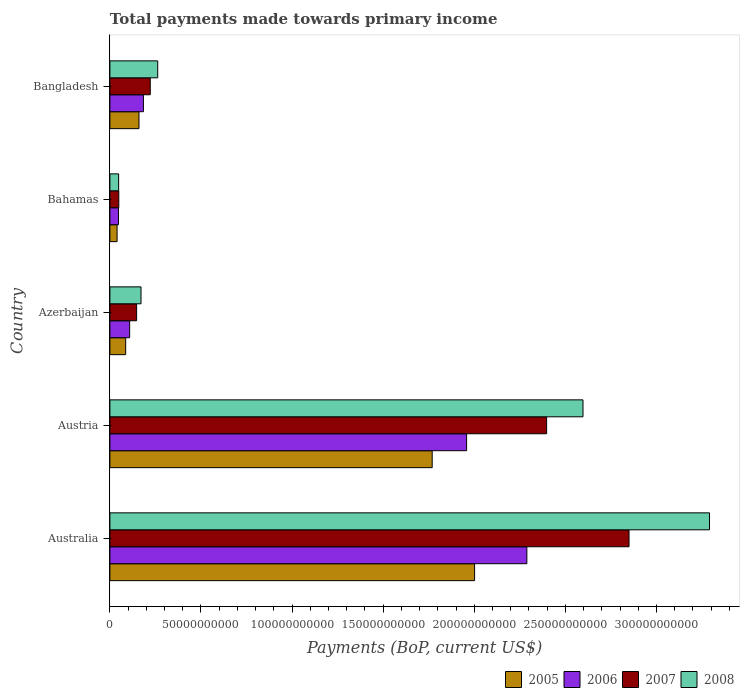How many groups of bars are there?
Provide a succinct answer. 5. Are the number of bars per tick equal to the number of legend labels?
Give a very brief answer. Yes. Are the number of bars on each tick of the Y-axis equal?
Your answer should be compact. Yes. How many bars are there on the 2nd tick from the top?
Give a very brief answer. 4. How many bars are there on the 3rd tick from the bottom?
Your answer should be very brief. 4. What is the label of the 2nd group of bars from the top?
Give a very brief answer. Bahamas. In how many cases, is the number of bars for a given country not equal to the number of legend labels?
Ensure brevity in your answer.  0. What is the total payments made towards primary income in 2005 in Azerbaijan?
Offer a terse response. 8.66e+09. Across all countries, what is the maximum total payments made towards primary income in 2007?
Your response must be concise. 2.85e+11. Across all countries, what is the minimum total payments made towards primary income in 2008?
Offer a terse response. 4.80e+09. In which country was the total payments made towards primary income in 2007 maximum?
Make the answer very short. Australia. In which country was the total payments made towards primary income in 2005 minimum?
Provide a short and direct response. Bahamas. What is the total total payments made towards primary income in 2008 in the graph?
Offer a very short reply. 6.37e+11. What is the difference between the total payments made towards primary income in 2007 in Australia and that in Austria?
Make the answer very short. 4.52e+1. What is the difference between the total payments made towards primary income in 2008 in Bangladesh and the total payments made towards primary income in 2005 in Azerbaijan?
Offer a very short reply. 1.76e+1. What is the average total payments made towards primary income in 2008 per country?
Offer a very short reply. 1.27e+11. What is the difference between the total payments made towards primary income in 2007 and total payments made towards primary income in 2008 in Austria?
Provide a succinct answer. -2.00e+1. What is the ratio of the total payments made towards primary income in 2008 in Austria to that in Bangladesh?
Your response must be concise. 9.89. Is the difference between the total payments made towards primary income in 2007 in Bahamas and Bangladesh greater than the difference between the total payments made towards primary income in 2008 in Bahamas and Bangladesh?
Ensure brevity in your answer.  Yes. What is the difference between the highest and the second highest total payments made towards primary income in 2008?
Give a very brief answer. 6.94e+1. What is the difference between the highest and the lowest total payments made towards primary income in 2006?
Your answer should be very brief. 2.24e+11. In how many countries, is the total payments made towards primary income in 2007 greater than the average total payments made towards primary income in 2007 taken over all countries?
Ensure brevity in your answer.  2. Is the sum of the total payments made towards primary income in 2008 in Austria and Bahamas greater than the maximum total payments made towards primary income in 2006 across all countries?
Your answer should be compact. Yes. What does the 2nd bar from the bottom in Australia represents?
Offer a very short reply. 2006. Is it the case that in every country, the sum of the total payments made towards primary income in 2008 and total payments made towards primary income in 2006 is greater than the total payments made towards primary income in 2005?
Your answer should be very brief. Yes. Are all the bars in the graph horizontal?
Provide a short and direct response. Yes. How many countries are there in the graph?
Your response must be concise. 5. Are the values on the major ticks of X-axis written in scientific E-notation?
Make the answer very short. No. How many legend labels are there?
Make the answer very short. 4. What is the title of the graph?
Ensure brevity in your answer.  Total payments made towards primary income. What is the label or title of the X-axis?
Your response must be concise. Payments (BoP, current US$). What is the label or title of the Y-axis?
Offer a very short reply. Country. What is the Payments (BoP, current US$) of 2005 in Australia?
Your response must be concise. 2.00e+11. What is the Payments (BoP, current US$) of 2006 in Australia?
Give a very brief answer. 2.29e+11. What is the Payments (BoP, current US$) in 2007 in Australia?
Your answer should be compact. 2.85e+11. What is the Payments (BoP, current US$) in 2008 in Australia?
Offer a very short reply. 3.29e+11. What is the Payments (BoP, current US$) of 2005 in Austria?
Your answer should be very brief. 1.77e+11. What is the Payments (BoP, current US$) of 2006 in Austria?
Keep it short and to the point. 1.96e+11. What is the Payments (BoP, current US$) of 2007 in Austria?
Ensure brevity in your answer.  2.40e+11. What is the Payments (BoP, current US$) of 2008 in Austria?
Give a very brief answer. 2.60e+11. What is the Payments (BoP, current US$) in 2005 in Azerbaijan?
Give a very brief answer. 8.66e+09. What is the Payments (BoP, current US$) in 2006 in Azerbaijan?
Offer a very short reply. 1.09e+1. What is the Payments (BoP, current US$) in 2007 in Azerbaijan?
Your answer should be compact. 1.47e+1. What is the Payments (BoP, current US$) in 2008 in Azerbaijan?
Your answer should be compact. 1.71e+1. What is the Payments (BoP, current US$) in 2005 in Bahamas?
Your response must be concise. 3.94e+09. What is the Payments (BoP, current US$) in 2006 in Bahamas?
Offer a terse response. 4.71e+09. What is the Payments (BoP, current US$) in 2007 in Bahamas?
Make the answer very short. 4.89e+09. What is the Payments (BoP, current US$) in 2008 in Bahamas?
Provide a succinct answer. 4.80e+09. What is the Payments (BoP, current US$) in 2005 in Bangladesh?
Offer a very short reply. 1.60e+1. What is the Payments (BoP, current US$) in 2006 in Bangladesh?
Ensure brevity in your answer.  1.84e+1. What is the Payments (BoP, current US$) in 2007 in Bangladesh?
Offer a terse response. 2.22e+1. What is the Payments (BoP, current US$) of 2008 in Bangladesh?
Ensure brevity in your answer.  2.62e+1. Across all countries, what is the maximum Payments (BoP, current US$) in 2005?
Your answer should be very brief. 2.00e+11. Across all countries, what is the maximum Payments (BoP, current US$) in 2006?
Ensure brevity in your answer.  2.29e+11. Across all countries, what is the maximum Payments (BoP, current US$) in 2007?
Offer a terse response. 2.85e+11. Across all countries, what is the maximum Payments (BoP, current US$) in 2008?
Keep it short and to the point. 3.29e+11. Across all countries, what is the minimum Payments (BoP, current US$) in 2005?
Provide a short and direct response. 3.94e+09. Across all countries, what is the minimum Payments (BoP, current US$) in 2006?
Give a very brief answer. 4.71e+09. Across all countries, what is the minimum Payments (BoP, current US$) in 2007?
Offer a very short reply. 4.89e+09. Across all countries, what is the minimum Payments (BoP, current US$) in 2008?
Ensure brevity in your answer.  4.80e+09. What is the total Payments (BoP, current US$) of 2005 in the graph?
Give a very brief answer. 4.06e+11. What is the total Payments (BoP, current US$) of 2006 in the graph?
Provide a short and direct response. 4.59e+11. What is the total Payments (BoP, current US$) of 2007 in the graph?
Give a very brief answer. 5.66e+11. What is the total Payments (BoP, current US$) of 2008 in the graph?
Offer a terse response. 6.37e+11. What is the difference between the Payments (BoP, current US$) in 2005 in Australia and that in Austria?
Your answer should be very brief. 2.33e+1. What is the difference between the Payments (BoP, current US$) in 2006 in Australia and that in Austria?
Offer a terse response. 3.31e+1. What is the difference between the Payments (BoP, current US$) of 2007 in Australia and that in Austria?
Provide a short and direct response. 4.52e+1. What is the difference between the Payments (BoP, current US$) of 2008 in Australia and that in Austria?
Ensure brevity in your answer.  6.94e+1. What is the difference between the Payments (BoP, current US$) of 2005 in Australia and that in Azerbaijan?
Keep it short and to the point. 1.92e+11. What is the difference between the Payments (BoP, current US$) of 2006 in Australia and that in Azerbaijan?
Your answer should be very brief. 2.18e+11. What is the difference between the Payments (BoP, current US$) of 2007 in Australia and that in Azerbaijan?
Ensure brevity in your answer.  2.70e+11. What is the difference between the Payments (BoP, current US$) of 2008 in Australia and that in Azerbaijan?
Keep it short and to the point. 3.12e+11. What is the difference between the Payments (BoP, current US$) of 2005 in Australia and that in Bahamas?
Give a very brief answer. 1.96e+11. What is the difference between the Payments (BoP, current US$) of 2006 in Australia and that in Bahamas?
Your answer should be very brief. 2.24e+11. What is the difference between the Payments (BoP, current US$) of 2007 in Australia and that in Bahamas?
Offer a very short reply. 2.80e+11. What is the difference between the Payments (BoP, current US$) of 2008 in Australia and that in Bahamas?
Your answer should be compact. 3.24e+11. What is the difference between the Payments (BoP, current US$) of 2005 in Australia and that in Bangladesh?
Your answer should be very brief. 1.84e+11. What is the difference between the Payments (BoP, current US$) in 2006 in Australia and that in Bangladesh?
Make the answer very short. 2.10e+11. What is the difference between the Payments (BoP, current US$) of 2007 in Australia and that in Bangladesh?
Keep it short and to the point. 2.63e+11. What is the difference between the Payments (BoP, current US$) of 2008 in Australia and that in Bangladesh?
Offer a terse response. 3.03e+11. What is the difference between the Payments (BoP, current US$) of 2005 in Austria and that in Azerbaijan?
Offer a terse response. 1.68e+11. What is the difference between the Payments (BoP, current US$) in 2006 in Austria and that in Azerbaijan?
Your answer should be compact. 1.85e+11. What is the difference between the Payments (BoP, current US$) in 2007 in Austria and that in Azerbaijan?
Keep it short and to the point. 2.25e+11. What is the difference between the Payments (BoP, current US$) of 2008 in Austria and that in Azerbaijan?
Give a very brief answer. 2.43e+11. What is the difference between the Payments (BoP, current US$) in 2005 in Austria and that in Bahamas?
Your response must be concise. 1.73e+11. What is the difference between the Payments (BoP, current US$) of 2006 in Austria and that in Bahamas?
Offer a terse response. 1.91e+11. What is the difference between the Payments (BoP, current US$) of 2007 in Austria and that in Bahamas?
Make the answer very short. 2.35e+11. What is the difference between the Payments (BoP, current US$) in 2008 in Austria and that in Bahamas?
Provide a short and direct response. 2.55e+11. What is the difference between the Payments (BoP, current US$) of 2005 in Austria and that in Bangladesh?
Ensure brevity in your answer.  1.61e+11. What is the difference between the Payments (BoP, current US$) of 2006 in Austria and that in Bangladesh?
Provide a succinct answer. 1.77e+11. What is the difference between the Payments (BoP, current US$) in 2007 in Austria and that in Bangladesh?
Keep it short and to the point. 2.18e+11. What is the difference between the Payments (BoP, current US$) of 2008 in Austria and that in Bangladesh?
Your response must be concise. 2.33e+11. What is the difference between the Payments (BoP, current US$) of 2005 in Azerbaijan and that in Bahamas?
Offer a terse response. 4.71e+09. What is the difference between the Payments (BoP, current US$) of 2006 in Azerbaijan and that in Bahamas?
Offer a terse response. 6.14e+09. What is the difference between the Payments (BoP, current US$) of 2007 in Azerbaijan and that in Bahamas?
Keep it short and to the point. 9.78e+09. What is the difference between the Payments (BoP, current US$) of 2008 in Azerbaijan and that in Bahamas?
Keep it short and to the point. 1.23e+1. What is the difference between the Payments (BoP, current US$) of 2005 in Azerbaijan and that in Bangladesh?
Offer a very short reply. -7.31e+09. What is the difference between the Payments (BoP, current US$) of 2006 in Azerbaijan and that in Bangladesh?
Provide a short and direct response. -7.55e+09. What is the difference between the Payments (BoP, current US$) in 2007 in Azerbaijan and that in Bangladesh?
Offer a terse response. -7.48e+09. What is the difference between the Payments (BoP, current US$) of 2008 in Azerbaijan and that in Bangladesh?
Your answer should be very brief. -9.17e+09. What is the difference between the Payments (BoP, current US$) in 2005 in Bahamas and that in Bangladesh?
Make the answer very short. -1.20e+1. What is the difference between the Payments (BoP, current US$) in 2006 in Bahamas and that in Bangladesh?
Give a very brief answer. -1.37e+1. What is the difference between the Payments (BoP, current US$) of 2007 in Bahamas and that in Bangladesh?
Your answer should be very brief. -1.73e+1. What is the difference between the Payments (BoP, current US$) in 2008 in Bahamas and that in Bangladesh?
Offer a very short reply. -2.14e+1. What is the difference between the Payments (BoP, current US$) of 2005 in Australia and the Payments (BoP, current US$) of 2006 in Austria?
Make the answer very short. 4.39e+09. What is the difference between the Payments (BoP, current US$) in 2005 in Australia and the Payments (BoP, current US$) in 2007 in Austria?
Offer a very short reply. -3.95e+1. What is the difference between the Payments (BoP, current US$) in 2005 in Australia and the Payments (BoP, current US$) in 2008 in Austria?
Your answer should be very brief. -5.95e+1. What is the difference between the Payments (BoP, current US$) of 2006 in Australia and the Payments (BoP, current US$) of 2007 in Austria?
Ensure brevity in your answer.  -1.08e+1. What is the difference between the Payments (BoP, current US$) in 2006 in Australia and the Payments (BoP, current US$) in 2008 in Austria?
Offer a very short reply. -3.08e+1. What is the difference between the Payments (BoP, current US$) in 2007 in Australia and the Payments (BoP, current US$) in 2008 in Austria?
Ensure brevity in your answer.  2.53e+1. What is the difference between the Payments (BoP, current US$) in 2005 in Australia and the Payments (BoP, current US$) in 2006 in Azerbaijan?
Give a very brief answer. 1.89e+11. What is the difference between the Payments (BoP, current US$) in 2005 in Australia and the Payments (BoP, current US$) in 2007 in Azerbaijan?
Offer a very short reply. 1.86e+11. What is the difference between the Payments (BoP, current US$) in 2005 in Australia and the Payments (BoP, current US$) in 2008 in Azerbaijan?
Keep it short and to the point. 1.83e+11. What is the difference between the Payments (BoP, current US$) in 2006 in Australia and the Payments (BoP, current US$) in 2007 in Azerbaijan?
Offer a terse response. 2.14e+11. What is the difference between the Payments (BoP, current US$) of 2006 in Australia and the Payments (BoP, current US$) of 2008 in Azerbaijan?
Provide a short and direct response. 2.12e+11. What is the difference between the Payments (BoP, current US$) of 2007 in Australia and the Payments (BoP, current US$) of 2008 in Azerbaijan?
Your answer should be compact. 2.68e+11. What is the difference between the Payments (BoP, current US$) in 2005 in Australia and the Payments (BoP, current US$) in 2006 in Bahamas?
Give a very brief answer. 1.95e+11. What is the difference between the Payments (BoP, current US$) of 2005 in Australia and the Payments (BoP, current US$) of 2007 in Bahamas?
Keep it short and to the point. 1.95e+11. What is the difference between the Payments (BoP, current US$) of 2005 in Australia and the Payments (BoP, current US$) of 2008 in Bahamas?
Offer a terse response. 1.95e+11. What is the difference between the Payments (BoP, current US$) of 2006 in Australia and the Payments (BoP, current US$) of 2007 in Bahamas?
Your response must be concise. 2.24e+11. What is the difference between the Payments (BoP, current US$) of 2006 in Australia and the Payments (BoP, current US$) of 2008 in Bahamas?
Your answer should be compact. 2.24e+11. What is the difference between the Payments (BoP, current US$) of 2007 in Australia and the Payments (BoP, current US$) of 2008 in Bahamas?
Your response must be concise. 2.80e+11. What is the difference between the Payments (BoP, current US$) of 2005 in Australia and the Payments (BoP, current US$) of 2006 in Bangladesh?
Your answer should be compact. 1.82e+11. What is the difference between the Payments (BoP, current US$) in 2005 in Australia and the Payments (BoP, current US$) in 2007 in Bangladesh?
Offer a terse response. 1.78e+11. What is the difference between the Payments (BoP, current US$) in 2005 in Australia and the Payments (BoP, current US$) in 2008 in Bangladesh?
Your answer should be compact. 1.74e+11. What is the difference between the Payments (BoP, current US$) of 2006 in Australia and the Payments (BoP, current US$) of 2007 in Bangladesh?
Provide a succinct answer. 2.07e+11. What is the difference between the Payments (BoP, current US$) in 2006 in Australia and the Payments (BoP, current US$) in 2008 in Bangladesh?
Your response must be concise. 2.03e+11. What is the difference between the Payments (BoP, current US$) in 2007 in Australia and the Payments (BoP, current US$) in 2008 in Bangladesh?
Your response must be concise. 2.59e+11. What is the difference between the Payments (BoP, current US$) in 2005 in Austria and the Payments (BoP, current US$) in 2006 in Azerbaijan?
Ensure brevity in your answer.  1.66e+11. What is the difference between the Payments (BoP, current US$) in 2005 in Austria and the Payments (BoP, current US$) in 2007 in Azerbaijan?
Ensure brevity in your answer.  1.62e+11. What is the difference between the Payments (BoP, current US$) in 2005 in Austria and the Payments (BoP, current US$) in 2008 in Azerbaijan?
Your response must be concise. 1.60e+11. What is the difference between the Payments (BoP, current US$) in 2006 in Austria and the Payments (BoP, current US$) in 2007 in Azerbaijan?
Your response must be concise. 1.81e+11. What is the difference between the Payments (BoP, current US$) of 2006 in Austria and the Payments (BoP, current US$) of 2008 in Azerbaijan?
Make the answer very short. 1.79e+11. What is the difference between the Payments (BoP, current US$) in 2007 in Austria and the Payments (BoP, current US$) in 2008 in Azerbaijan?
Offer a terse response. 2.23e+11. What is the difference between the Payments (BoP, current US$) in 2005 in Austria and the Payments (BoP, current US$) in 2006 in Bahamas?
Make the answer very short. 1.72e+11. What is the difference between the Payments (BoP, current US$) of 2005 in Austria and the Payments (BoP, current US$) of 2007 in Bahamas?
Your answer should be compact. 1.72e+11. What is the difference between the Payments (BoP, current US$) in 2005 in Austria and the Payments (BoP, current US$) in 2008 in Bahamas?
Your answer should be very brief. 1.72e+11. What is the difference between the Payments (BoP, current US$) of 2006 in Austria and the Payments (BoP, current US$) of 2007 in Bahamas?
Ensure brevity in your answer.  1.91e+11. What is the difference between the Payments (BoP, current US$) of 2006 in Austria and the Payments (BoP, current US$) of 2008 in Bahamas?
Offer a terse response. 1.91e+11. What is the difference between the Payments (BoP, current US$) in 2007 in Austria and the Payments (BoP, current US$) in 2008 in Bahamas?
Ensure brevity in your answer.  2.35e+11. What is the difference between the Payments (BoP, current US$) of 2005 in Austria and the Payments (BoP, current US$) of 2006 in Bangladesh?
Offer a terse response. 1.59e+11. What is the difference between the Payments (BoP, current US$) of 2005 in Austria and the Payments (BoP, current US$) of 2007 in Bangladesh?
Your answer should be very brief. 1.55e+11. What is the difference between the Payments (BoP, current US$) of 2005 in Austria and the Payments (BoP, current US$) of 2008 in Bangladesh?
Your answer should be compact. 1.51e+11. What is the difference between the Payments (BoP, current US$) of 2006 in Austria and the Payments (BoP, current US$) of 2007 in Bangladesh?
Keep it short and to the point. 1.74e+11. What is the difference between the Payments (BoP, current US$) in 2006 in Austria and the Payments (BoP, current US$) in 2008 in Bangladesh?
Your answer should be very brief. 1.70e+11. What is the difference between the Payments (BoP, current US$) of 2007 in Austria and the Payments (BoP, current US$) of 2008 in Bangladesh?
Ensure brevity in your answer.  2.13e+11. What is the difference between the Payments (BoP, current US$) in 2005 in Azerbaijan and the Payments (BoP, current US$) in 2006 in Bahamas?
Provide a short and direct response. 3.94e+09. What is the difference between the Payments (BoP, current US$) in 2005 in Azerbaijan and the Payments (BoP, current US$) in 2007 in Bahamas?
Provide a succinct answer. 3.77e+09. What is the difference between the Payments (BoP, current US$) in 2005 in Azerbaijan and the Payments (BoP, current US$) in 2008 in Bahamas?
Keep it short and to the point. 3.86e+09. What is the difference between the Payments (BoP, current US$) in 2006 in Azerbaijan and the Payments (BoP, current US$) in 2007 in Bahamas?
Your answer should be very brief. 5.96e+09. What is the difference between the Payments (BoP, current US$) of 2006 in Azerbaijan and the Payments (BoP, current US$) of 2008 in Bahamas?
Provide a succinct answer. 6.05e+09. What is the difference between the Payments (BoP, current US$) of 2007 in Azerbaijan and the Payments (BoP, current US$) of 2008 in Bahamas?
Offer a very short reply. 9.87e+09. What is the difference between the Payments (BoP, current US$) of 2005 in Azerbaijan and the Payments (BoP, current US$) of 2006 in Bangladesh?
Provide a short and direct response. -9.74e+09. What is the difference between the Payments (BoP, current US$) of 2005 in Azerbaijan and the Payments (BoP, current US$) of 2007 in Bangladesh?
Your response must be concise. -1.35e+1. What is the difference between the Payments (BoP, current US$) of 2005 in Azerbaijan and the Payments (BoP, current US$) of 2008 in Bangladesh?
Your response must be concise. -1.76e+1. What is the difference between the Payments (BoP, current US$) in 2006 in Azerbaijan and the Payments (BoP, current US$) in 2007 in Bangladesh?
Give a very brief answer. -1.13e+1. What is the difference between the Payments (BoP, current US$) of 2006 in Azerbaijan and the Payments (BoP, current US$) of 2008 in Bangladesh?
Provide a succinct answer. -1.54e+1. What is the difference between the Payments (BoP, current US$) in 2007 in Azerbaijan and the Payments (BoP, current US$) in 2008 in Bangladesh?
Offer a very short reply. -1.16e+1. What is the difference between the Payments (BoP, current US$) of 2005 in Bahamas and the Payments (BoP, current US$) of 2006 in Bangladesh?
Keep it short and to the point. -1.45e+1. What is the difference between the Payments (BoP, current US$) in 2005 in Bahamas and the Payments (BoP, current US$) in 2007 in Bangladesh?
Your response must be concise. -1.82e+1. What is the difference between the Payments (BoP, current US$) of 2005 in Bahamas and the Payments (BoP, current US$) of 2008 in Bangladesh?
Make the answer very short. -2.23e+1. What is the difference between the Payments (BoP, current US$) in 2006 in Bahamas and the Payments (BoP, current US$) in 2007 in Bangladesh?
Offer a very short reply. -1.74e+1. What is the difference between the Payments (BoP, current US$) of 2006 in Bahamas and the Payments (BoP, current US$) of 2008 in Bangladesh?
Provide a succinct answer. -2.15e+1. What is the difference between the Payments (BoP, current US$) of 2007 in Bahamas and the Payments (BoP, current US$) of 2008 in Bangladesh?
Keep it short and to the point. -2.14e+1. What is the average Payments (BoP, current US$) of 2005 per country?
Offer a very short reply. 8.11e+1. What is the average Payments (BoP, current US$) of 2006 per country?
Provide a succinct answer. 9.17e+1. What is the average Payments (BoP, current US$) of 2007 per country?
Ensure brevity in your answer.  1.13e+11. What is the average Payments (BoP, current US$) of 2008 per country?
Make the answer very short. 1.27e+11. What is the difference between the Payments (BoP, current US$) of 2005 and Payments (BoP, current US$) of 2006 in Australia?
Your answer should be very brief. -2.87e+1. What is the difference between the Payments (BoP, current US$) in 2005 and Payments (BoP, current US$) in 2007 in Australia?
Provide a succinct answer. -8.48e+1. What is the difference between the Payments (BoP, current US$) of 2005 and Payments (BoP, current US$) of 2008 in Australia?
Make the answer very short. -1.29e+11. What is the difference between the Payments (BoP, current US$) of 2006 and Payments (BoP, current US$) of 2007 in Australia?
Make the answer very short. -5.61e+1. What is the difference between the Payments (BoP, current US$) in 2006 and Payments (BoP, current US$) in 2008 in Australia?
Provide a succinct answer. -1.00e+11. What is the difference between the Payments (BoP, current US$) in 2007 and Payments (BoP, current US$) in 2008 in Australia?
Provide a succinct answer. -4.42e+1. What is the difference between the Payments (BoP, current US$) of 2005 and Payments (BoP, current US$) of 2006 in Austria?
Offer a terse response. -1.89e+1. What is the difference between the Payments (BoP, current US$) in 2005 and Payments (BoP, current US$) in 2007 in Austria?
Offer a terse response. -6.28e+1. What is the difference between the Payments (BoP, current US$) in 2005 and Payments (BoP, current US$) in 2008 in Austria?
Give a very brief answer. -8.28e+1. What is the difference between the Payments (BoP, current US$) in 2006 and Payments (BoP, current US$) in 2007 in Austria?
Make the answer very short. -4.39e+1. What is the difference between the Payments (BoP, current US$) in 2006 and Payments (BoP, current US$) in 2008 in Austria?
Offer a terse response. -6.39e+1. What is the difference between the Payments (BoP, current US$) in 2007 and Payments (BoP, current US$) in 2008 in Austria?
Provide a short and direct response. -2.00e+1. What is the difference between the Payments (BoP, current US$) of 2005 and Payments (BoP, current US$) of 2006 in Azerbaijan?
Provide a short and direct response. -2.20e+09. What is the difference between the Payments (BoP, current US$) of 2005 and Payments (BoP, current US$) of 2007 in Azerbaijan?
Your answer should be very brief. -6.01e+09. What is the difference between the Payments (BoP, current US$) in 2005 and Payments (BoP, current US$) in 2008 in Azerbaijan?
Give a very brief answer. -8.42e+09. What is the difference between the Payments (BoP, current US$) in 2006 and Payments (BoP, current US$) in 2007 in Azerbaijan?
Provide a succinct answer. -3.82e+09. What is the difference between the Payments (BoP, current US$) in 2006 and Payments (BoP, current US$) in 2008 in Azerbaijan?
Your answer should be very brief. -6.23e+09. What is the difference between the Payments (BoP, current US$) in 2007 and Payments (BoP, current US$) in 2008 in Azerbaijan?
Your response must be concise. -2.41e+09. What is the difference between the Payments (BoP, current US$) of 2005 and Payments (BoP, current US$) of 2006 in Bahamas?
Your response must be concise. -7.72e+08. What is the difference between the Payments (BoP, current US$) of 2005 and Payments (BoP, current US$) of 2007 in Bahamas?
Your answer should be very brief. -9.46e+08. What is the difference between the Payments (BoP, current US$) of 2005 and Payments (BoP, current US$) of 2008 in Bahamas?
Provide a succinct answer. -8.58e+08. What is the difference between the Payments (BoP, current US$) of 2006 and Payments (BoP, current US$) of 2007 in Bahamas?
Offer a very short reply. -1.75e+08. What is the difference between the Payments (BoP, current US$) of 2006 and Payments (BoP, current US$) of 2008 in Bahamas?
Your answer should be very brief. -8.58e+07. What is the difference between the Payments (BoP, current US$) of 2007 and Payments (BoP, current US$) of 2008 in Bahamas?
Give a very brief answer. 8.88e+07. What is the difference between the Payments (BoP, current US$) in 2005 and Payments (BoP, current US$) in 2006 in Bangladesh?
Your response must be concise. -2.43e+09. What is the difference between the Payments (BoP, current US$) in 2005 and Payments (BoP, current US$) in 2007 in Bangladesh?
Make the answer very short. -6.18e+09. What is the difference between the Payments (BoP, current US$) of 2005 and Payments (BoP, current US$) of 2008 in Bangladesh?
Provide a short and direct response. -1.03e+1. What is the difference between the Payments (BoP, current US$) in 2006 and Payments (BoP, current US$) in 2007 in Bangladesh?
Make the answer very short. -3.75e+09. What is the difference between the Payments (BoP, current US$) of 2006 and Payments (BoP, current US$) of 2008 in Bangladesh?
Provide a succinct answer. -7.85e+09. What is the difference between the Payments (BoP, current US$) in 2007 and Payments (BoP, current US$) in 2008 in Bangladesh?
Your answer should be very brief. -4.10e+09. What is the ratio of the Payments (BoP, current US$) in 2005 in Australia to that in Austria?
Offer a terse response. 1.13. What is the ratio of the Payments (BoP, current US$) of 2006 in Australia to that in Austria?
Ensure brevity in your answer.  1.17. What is the ratio of the Payments (BoP, current US$) of 2007 in Australia to that in Austria?
Provide a succinct answer. 1.19. What is the ratio of the Payments (BoP, current US$) of 2008 in Australia to that in Austria?
Your answer should be compact. 1.27. What is the ratio of the Payments (BoP, current US$) in 2005 in Australia to that in Azerbaijan?
Make the answer very short. 23.12. What is the ratio of the Payments (BoP, current US$) of 2006 in Australia to that in Azerbaijan?
Provide a short and direct response. 21.09. What is the ratio of the Payments (BoP, current US$) in 2007 in Australia to that in Azerbaijan?
Offer a terse response. 19.43. What is the ratio of the Payments (BoP, current US$) in 2008 in Australia to that in Azerbaijan?
Offer a terse response. 19.27. What is the ratio of the Payments (BoP, current US$) of 2005 in Australia to that in Bahamas?
Your answer should be compact. 50.77. What is the ratio of the Payments (BoP, current US$) in 2006 in Australia to that in Bahamas?
Make the answer very short. 48.54. What is the ratio of the Payments (BoP, current US$) in 2007 in Australia to that in Bahamas?
Your answer should be compact. 58.28. What is the ratio of the Payments (BoP, current US$) in 2008 in Australia to that in Bahamas?
Offer a very short reply. 68.56. What is the ratio of the Payments (BoP, current US$) in 2005 in Australia to that in Bangladesh?
Offer a very short reply. 12.54. What is the ratio of the Payments (BoP, current US$) in 2006 in Australia to that in Bangladesh?
Your response must be concise. 12.44. What is the ratio of the Payments (BoP, current US$) of 2007 in Australia to that in Bangladesh?
Offer a very short reply. 12.86. What is the ratio of the Payments (BoP, current US$) in 2008 in Australia to that in Bangladesh?
Provide a short and direct response. 12.54. What is the ratio of the Payments (BoP, current US$) of 2005 in Austria to that in Azerbaijan?
Your answer should be compact. 20.43. What is the ratio of the Payments (BoP, current US$) of 2006 in Austria to that in Azerbaijan?
Give a very brief answer. 18.04. What is the ratio of the Payments (BoP, current US$) in 2007 in Austria to that in Azerbaijan?
Keep it short and to the point. 16.34. What is the ratio of the Payments (BoP, current US$) in 2008 in Austria to that in Azerbaijan?
Your answer should be compact. 15.2. What is the ratio of the Payments (BoP, current US$) of 2005 in Austria to that in Bahamas?
Your response must be concise. 44.87. What is the ratio of the Payments (BoP, current US$) of 2006 in Austria to that in Bahamas?
Offer a very short reply. 41.53. What is the ratio of the Payments (BoP, current US$) in 2007 in Austria to that in Bahamas?
Your answer should be very brief. 49.03. What is the ratio of the Payments (BoP, current US$) in 2008 in Austria to that in Bahamas?
Offer a terse response. 54.09. What is the ratio of the Payments (BoP, current US$) of 2005 in Austria to that in Bangladesh?
Provide a short and direct response. 11.08. What is the ratio of the Payments (BoP, current US$) in 2006 in Austria to that in Bangladesh?
Your answer should be compact. 10.64. What is the ratio of the Payments (BoP, current US$) in 2007 in Austria to that in Bangladesh?
Give a very brief answer. 10.82. What is the ratio of the Payments (BoP, current US$) in 2008 in Austria to that in Bangladesh?
Your response must be concise. 9.89. What is the ratio of the Payments (BoP, current US$) in 2005 in Azerbaijan to that in Bahamas?
Give a very brief answer. 2.2. What is the ratio of the Payments (BoP, current US$) of 2006 in Azerbaijan to that in Bahamas?
Offer a terse response. 2.3. What is the ratio of the Payments (BoP, current US$) of 2007 in Azerbaijan to that in Bahamas?
Provide a short and direct response. 3. What is the ratio of the Payments (BoP, current US$) of 2008 in Azerbaijan to that in Bahamas?
Ensure brevity in your answer.  3.56. What is the ratio of the Payments (BoP, current US$) in 2005 in Azerbaijan to that in Bangladesh?
Your answer should be very brief. 0.54. What is the ratio of the Payments (BoP, current US$) of 2006 in Azerbaijan to that in Bangladesh?
Provide a short and direct response. 0.59. What is the ratio of the Payments (BoP, current US$) in 2007 in Azerbaijan to that in Bangladesh?
Your answer should be very brief. 0.66. What is the ratio of the Payments (BoP, current US$) of 2008 in Azerbaijan to that in Bangladesh?
Offer a terse response. 0.65. What is the ratio of the Payments (BoP, current US$) of 2005 in Bahamas to that in Bangladesh?
Offer a terse response. 0.25. What is the ratio of the Payments (BoP, current US$) of 2006 in Bahamas to that in Bangladesh?
Provide a succinct answer. 0.26. What is the ratio of the Payments (BoP, current US$) of 2007 in Bahamas to that in Bangladesh?
Provide a succinct answer. 0.22. What is the ratio of the Payments (BoP, current US$) in 2008 in Bahamas to that in Bangladesh?
Ensure brevity in your answer.  0.18. What is the difference between the highest and the second highest Payments (BoP, current US$) in 2005?
Your response must be concise. 2.33e+1. What is the difference between the highest and the second highest Payments (BoP, current US$) in 2006?
Ensure brevity in your answer.  3.31e+1. What is the difference between the highest and the second highest Payments (BoP, current US$) in 2007?
Make the answer very short. 4.52e+1. What is the difference between the highest and the second highest Payments (BoP, current US$) in 2008?
Provide a short and direct response. 6.94e+1. What is the difference between the highest and the lowest Payments (BoP, current US$) of 2005?
Provide a short and direct response. 1.96e+11. What is the difference between the highest and the lowest Payments (BoP, current US$) in 2006?
Your answer should be compact. 2.24e+11. What is the difference between the highest and the lowest Payments (BoP, current US$) of 2007?
Provide a succinct answer. 2.80e+11. What is the difference between the highest and the lowest Payments (BoP, current US$) in 2008?
Your response must be concise. 3.24e+11. 